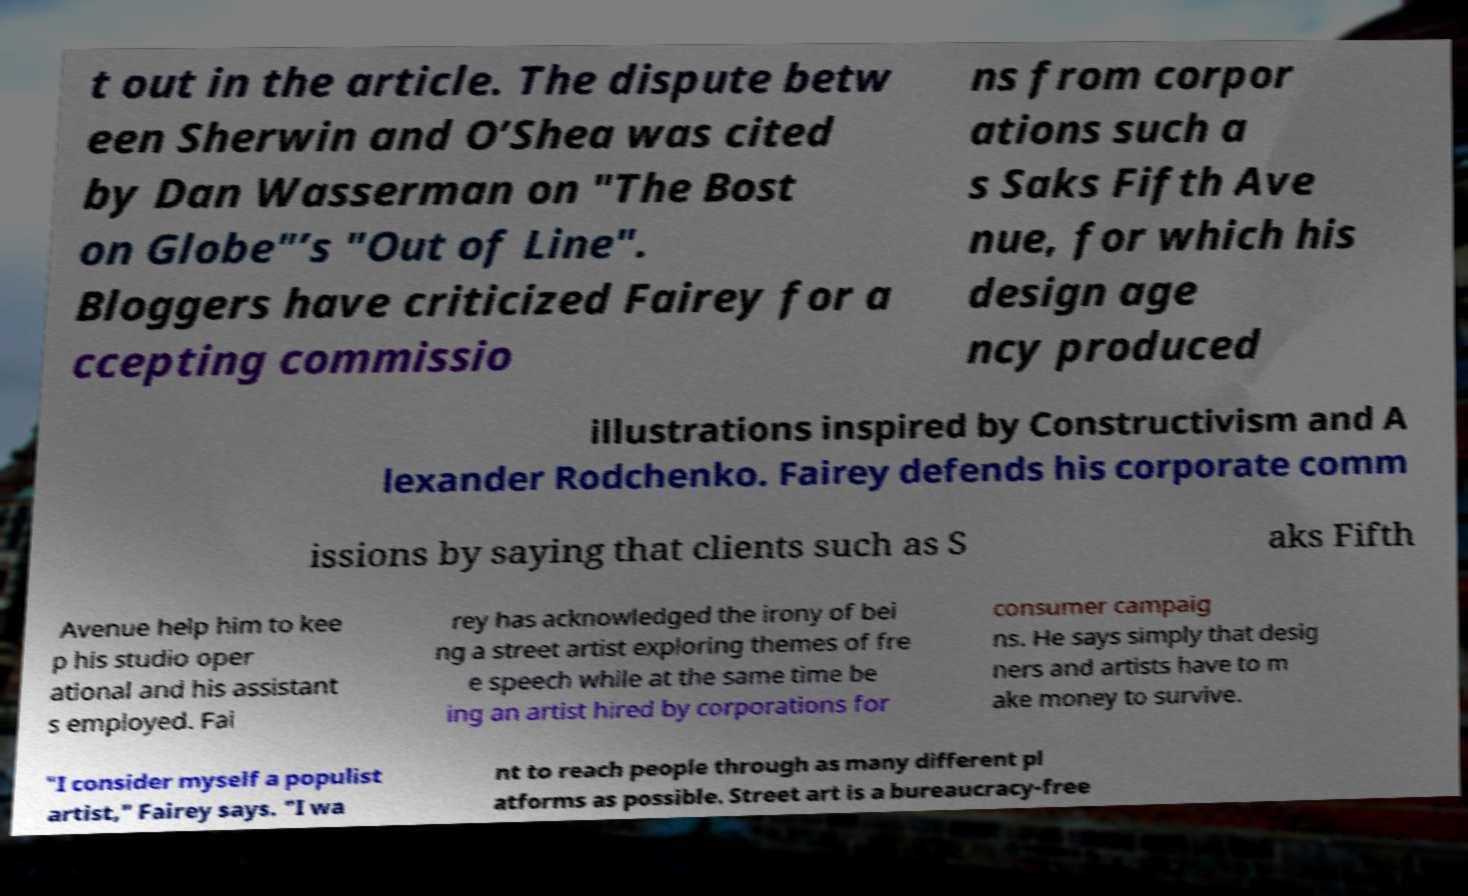Could you assist in decoding the text presented in this image and type it out clearly? t out in the article. The dispute betw een Sherwin and O’Shea was cited by Dan Wasserman on "The Bost on Globe"’s "Out of Line". Bloggers have criticized Fairey for a ccepting commissio ns from corpor ations such a s Saks Fifth Ave nue, for which his design age ncy produced illustrations inspired by Constructivism and A lexander Rodchenko. Fairey defends his corporate comm issions by saying that clients such as S aks Fifth Avenue help him to kee p his studio oper ational and his assistant s employed. Fai rey has acknowledged the irony of bei ng a street artist exploring themes of fre e speech while at the same time be ing an artist hired by corporations for consumer campaig ns. He says simply that desig ners and artists have to m ake money to survive. "I consider myself a populist artist," Fairey says. "I wa nt to reach people through as many different pl atforms as possible. Street art is a bureaucracy-free 